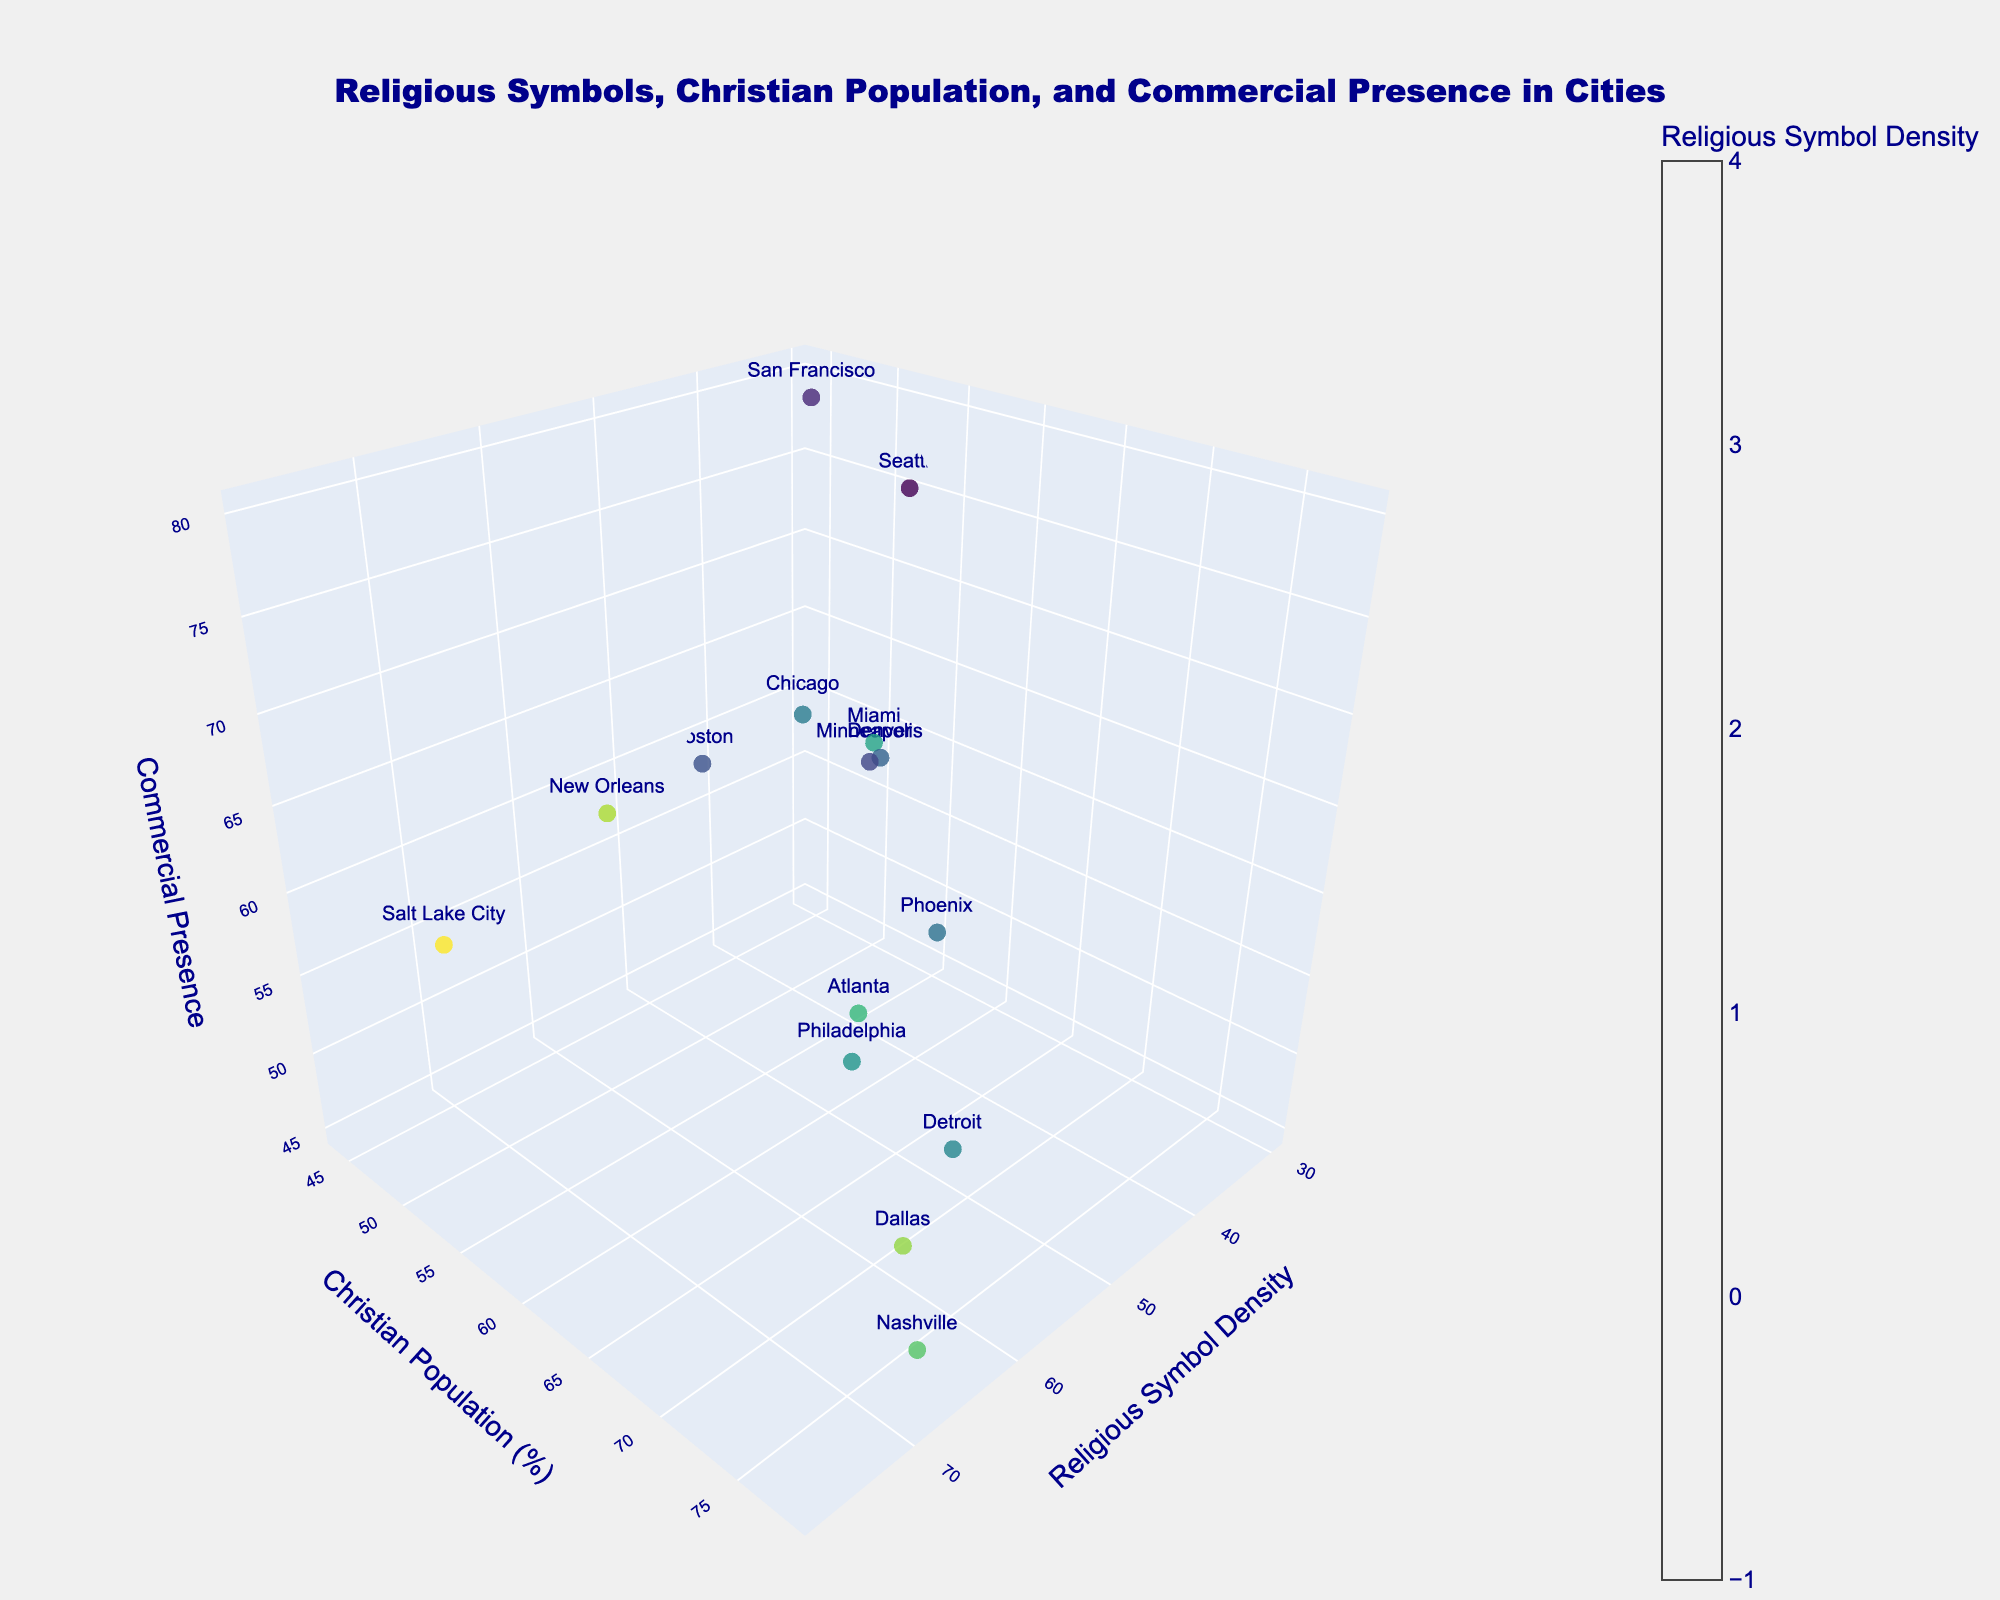What's the title of the figure? The title is located at the top center of the plot. It reads: "Religious Symbols, Christian Population, and Commercial Presence in Cities".
Answer: Religious Symbols, Christian Population, and Commercial Presence in Cities How many cities are represented in the plot? By counting the number of data points (markers) in the 3D space, we can determine the number of cities. There are 15 cities represented.
Answer: 15 Which city has the highest density of religious symbols? By examining the x-axis for the highest value in Religious Symbol Density and looking at the associated marker and text, we see it is Salt Lake City.
Answer: Salt Lake City What is the relationship between religious symbol density and the commercial presence in cities? By observing how the points are spread in the x (Religious Symbol Density) and z (Commercial Presence) axes, we see that there isn’t a clear trend showing that higher density of religious symbols coincides with either high or low commercial presence directly.
Answer: No clear trend Which city has the lowest commercial presence and what is its religious symbol density? Looking at the z-axis for the lowest value in Commercial Presence, we find Detroit. Correspondingly, its religious symbol density is 52.
Answer: Detroit, 52 Compare Atlanta and Seattle in terms of Christian population percentage and commercial presence. Atlanta has a higher Christian population percentage (70%) compared to Seattle (52%). However, Seattle has higher commercial presence (75%) than Atlanta (60%).
Answer: Atlanta: 70%, 60%; Seattle: 52%, 75% Which cities have a Christian population percentage greater than 65%? By reading from the y-axis and identifying the corresponding markers and texts, the cities are Dallas (78%), Miami (68%), Phoenix (66%), Philadelphia (65%), Detroit (70%), and Nashville (76%).
Answer: Dallas, Miami, Phoenix, Philadelphia, Detroit, Nashville What's the median value of the religious symbol density among all cities? To find the median, arrange the religious symbol densities in numerical order (30, 35, 40, 42, 45, 48, 50, 52, 55, 58, 62, 65, 70, 72, 78). The median value is the 8th number in this sequence, which is 52.
Answer: 52 Does a higher percentage of the Christian population correlate with higher or lower religious symbol density? By analyzing the trend in the plot along the x (Religious Symbol Density) and y (Christian Population Percentage) axes, it appears that cities with a higher percentage of the Christian population do not necessarily have a higher religious symbol density, showing no consistent correlation.
Answer: No consistent correlation What is the most common range (10-unit interval) for commercial presence among the cities? By segmenting the z-axis into intervals (40-50, 50-60, 60-70, etc.) and counting data points in each range, the interval 50-60 includes 5 cities (Boston, Philadelphia, Dallas, Minneapolis, Detroit), making it the most common range.
Answer: 50-60 